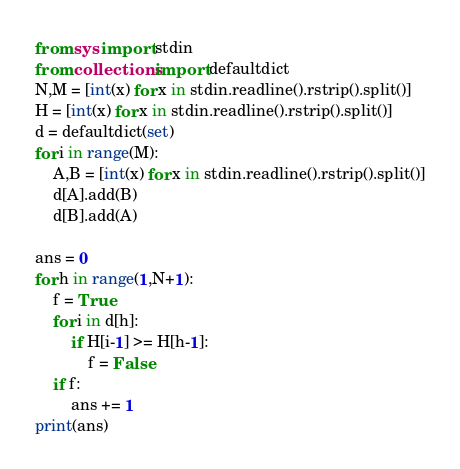Convert code to text. <code><loc_0><loc_0><loc_500><loc_500><_Python_>from sys import stdin
from collections import defaultdict
N,M = [int(x) for x in stdin.readline().rstrip().split()]
H = [int(x) for x in stdin.readline().rstrip().split()]
d = defaultdict(set)
for i in range(M):
    A,B = [int(x) for x in stdin.readline().rstrip().split()]
    d[A].add(B)
    d[B].add(A)
    
ans = 0
for h in range(1,N+1):
    f = True
    for i in d[h]:
        if H[i-1] >= H[h-1]:
            f = False
    if f:
        ans += 1
print(ans)</code> 